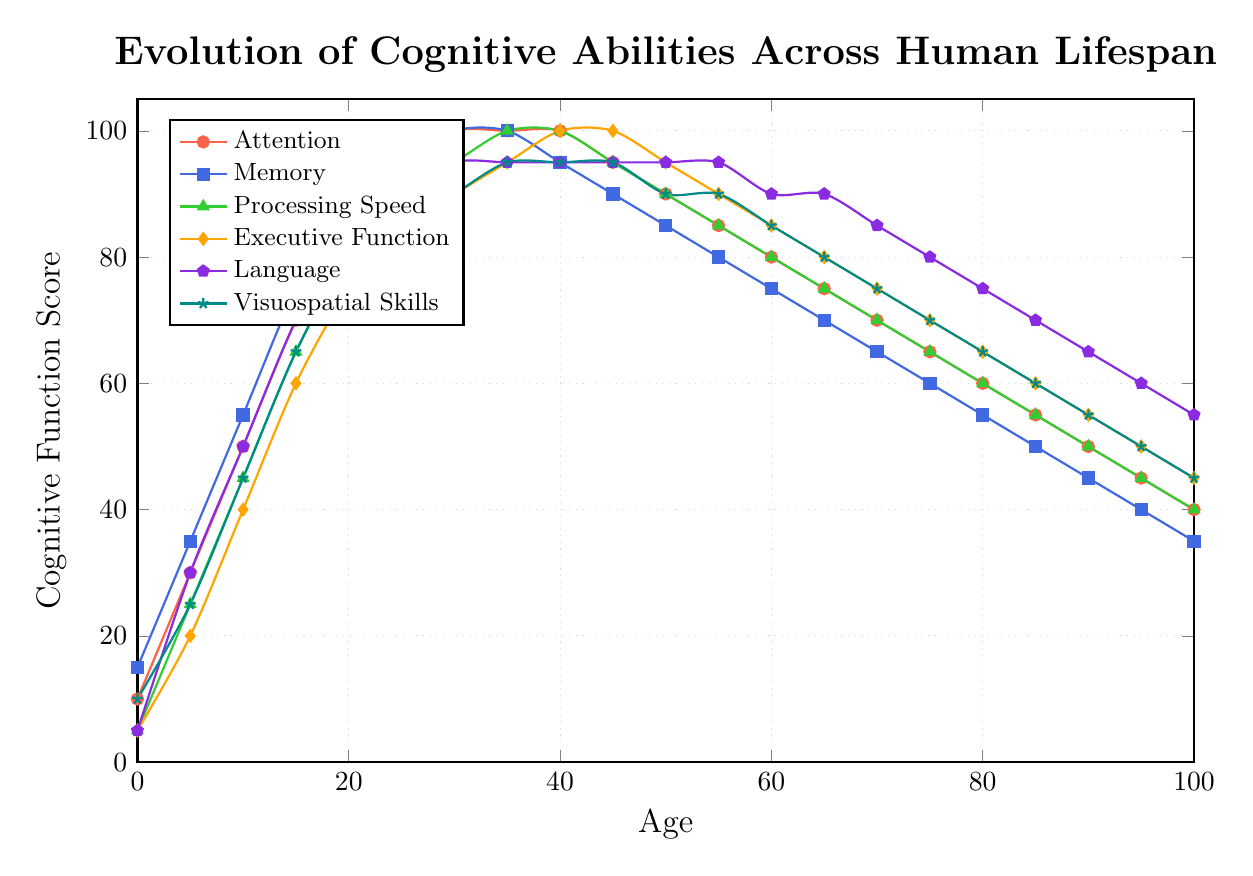What age group shows the peak in processing speed? The peak in processing speed occurs at the age with the highest value on the green line representing Processing Speed. From the figure, the peak value of 100 is reached at ages 35 and 40.
Answer: Ages 35 and 40 At what age does memory reach its highest value and what is that value? To find the highest value for memory, look for the highest point on the blue line. The highest value is 100, which occurs at ages 30 and 35.
Answer: Age 30 and 35, value 100 Which cognitive function shows the earliest peak, and at what age? By inspecting the highest points across all lines, the earliest peak is identified. Attention peaks first at age 30 with a value of 100.
Answer: Attention, Age 30 How does the visuospatial skills score at age 50 compare to that at age 85? Check the values on the cyan line at ages 50 and 85. At age 50, the score is 90, and at age 85, it is 60. The score at age 50 is 30 points higher than at age 85.
Answer: 30 points higher at age 50 What is the average score of executive function between ages 45 and 65 inclusive? Identify the values for Executive Function (orange line) at ages 45, 50, 55, 60, and 65: 100, 95, 90, 85, and 80. Sum these values (100 + 95 + 90 + 85 + 80 = 450) and divide by the number of data points (5). The average score is 450 / 5 = 90.
Answer: 90 Which cognitive functions have a higher score than memory at age 55? At age 55, the memory score (blue line) is 80. Compare this with values of other lines at age 55: Attention (85), Processing Speed (85), Executive Function (90), Language (95), and Visuospatial Skills (90). All other cognitive functions have higher scores than Memory at this age.
Answer: All cognitive functions At what ages does language have a higher value than processing speed? Compare the values on the purple line (Language) to the green line (Processing Speed) across all ages. Language has a higher value at ages 0, 5, 10, 15, 20, 25, and 100.
Answer: Ages 0, 5, 10, 15, 20, 25, 100 Between ages 60 and 80, which cognitive function shows the least decline? Identify the slope of the lines between ages 60 and 80. Compare values at ages 60 and 80: Attention (80 to 60), Memory (75 to 55), Processing Speed (80 to 60), Executive Function (85 to 65), Language (90 to 75), and Visuospatial Skills (85 to 65). The least decline is in Language, decreasing by 15 points.
Answer: Language What is the difference in attention score between ages 20 and 75? Find the values for Attention (red line) at ages 20 and 75: 85 and 65 respectively. The difference is 85 - 65 = 20.
Answer: 20 How do the scores for executive function and visuospatial skills compare at age 100? The values at age 100 for Executive Function (orange line) and Visuospatial Skills (cyan line) are 45 and 45 respectively. Both scores are equal.
Answer: Scores are equal 